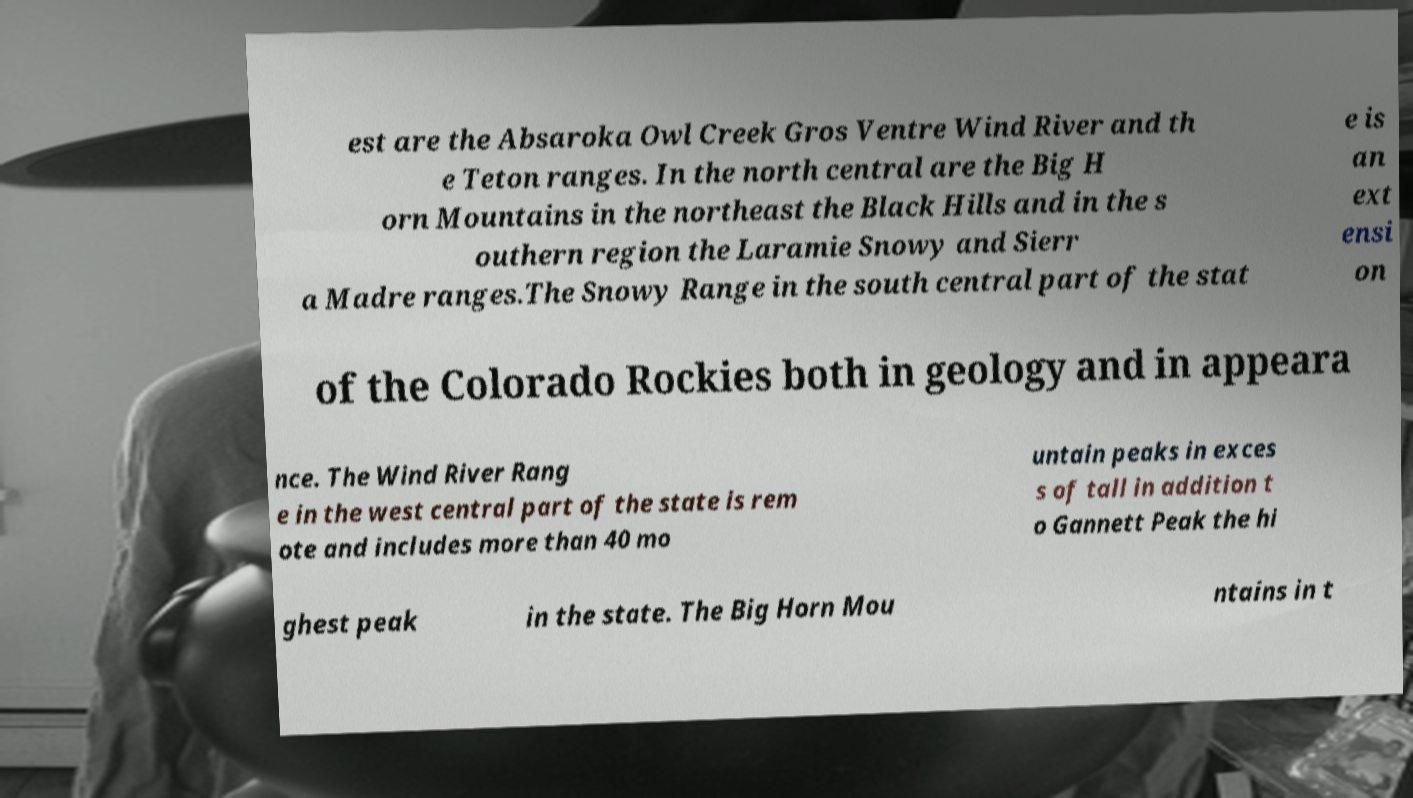There's text embedded in this image that I need extracted. Can you transcribe it verbatim? est are the Absaroka Owl Creek Gros Ventre Wind River and th e Teton ranges. In the north central are the Big H orn Mountains in the northeast the Black Hills and in the s outhern region the Laramie Snowy and Sierr a Madre ranges.The Snowy Range in the south central part of the stat e is an ext ensi on of the Colorado Rockies both in geology and in appeara nce. The Wind River Rang e in the west central part of the state is rem ote and includes more than 40 mo untain peaks in exces s of tall in addition t o Gannett Peak the hi ghest peak in the state. The Big Horn Mou ntains in t 